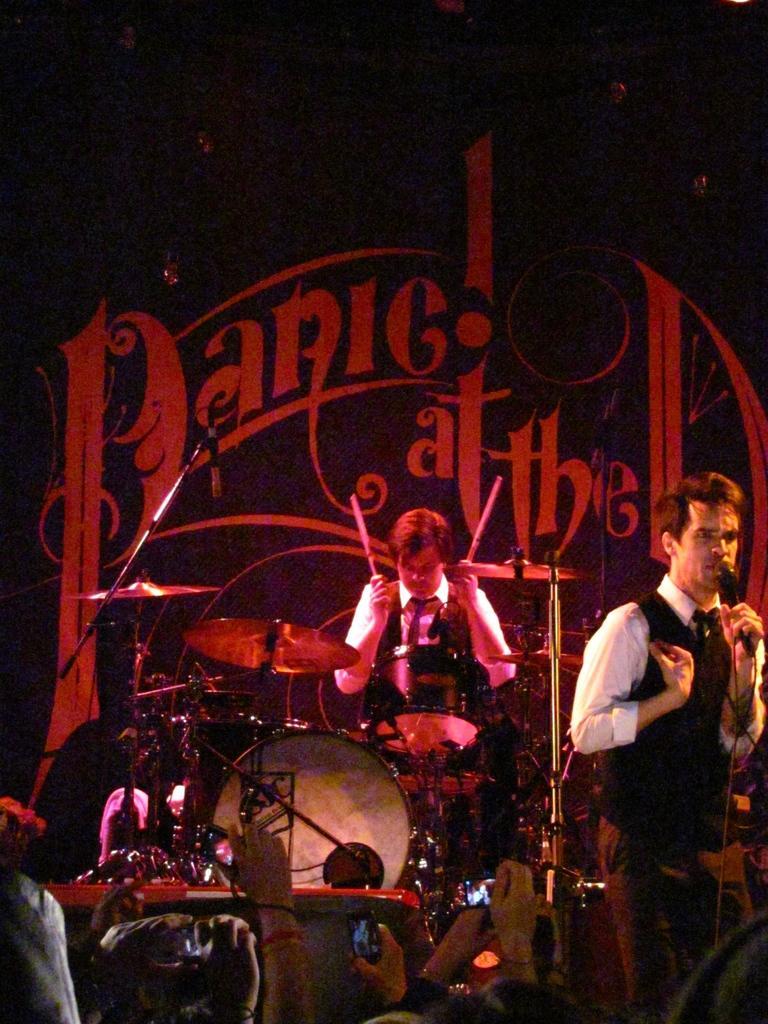How would you summarize this image in a sentence or two? This might be clicked in a musical concert. There are two persons in this image. The one who is on the right side is holding mic and singing something. The one who is in the middle is playing drums. 